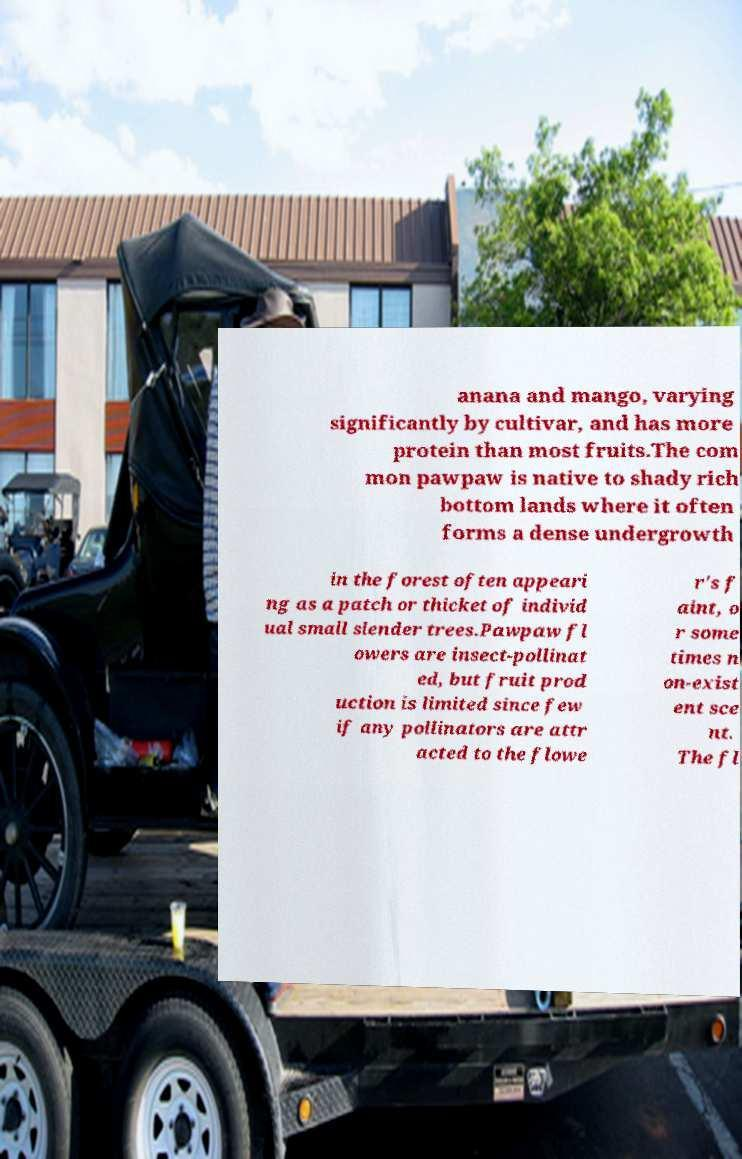Can you read and provide the text displayed in the image?This photo seems to have some interesting text. Can you extract and type it out for me? anana and mango, varying significantly by cultivar, and has more protein than most fruits.The com mon pawpaw is native to shady rich bottom lands where it often forms a dense undergrowth in the forest often appeari ng as a patch or thicket of individ ual small slender trees.Pawpaw fl owers are insect-pollinat ed, but fruit prod uction is limited since few if any pollinators are attr acted to the flowe r's f aint, o r some times n on-exist ent sce nt. The fl 